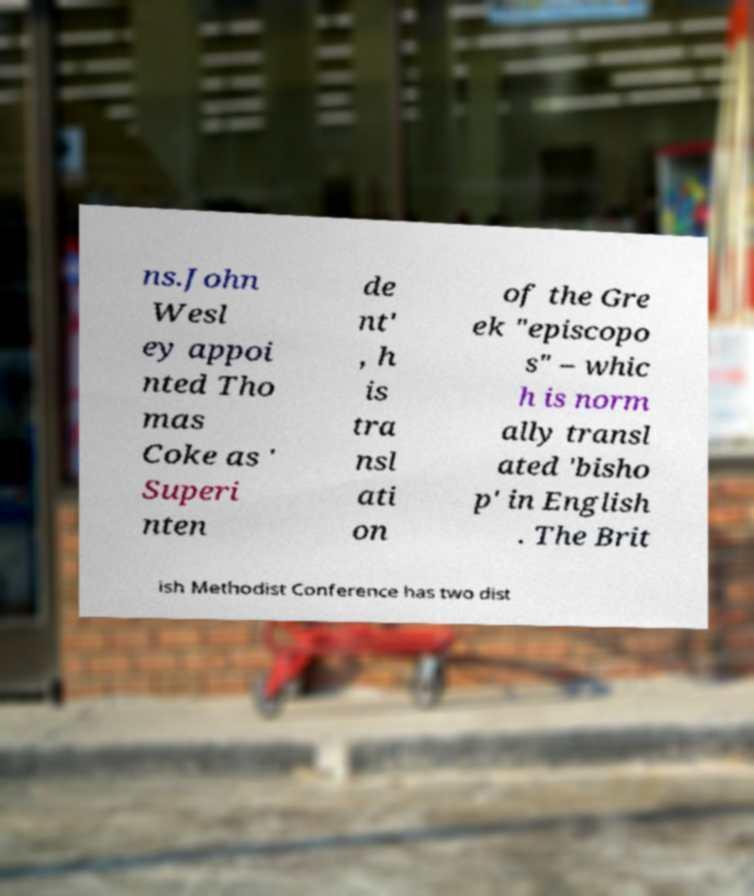Can you accurately transcribe the text from the provided image for me? ns.John Wesl ey appoi nted Tho mas Coke as ' Superi nten de nt' , h is tra nsl ati on of the Gre ek "episcopo s" – whic h is norm ally transl ated 'bisho p' in English . The Brit ish Methodist Conference has two dist 